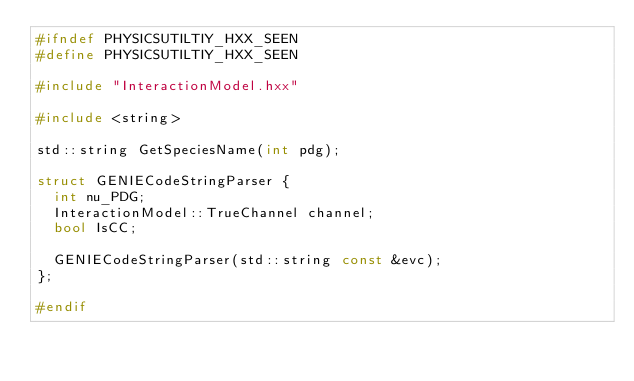<code> <loc_0><loc_0><loc_500><loc_500><_C++_>#ifndef PHYSICSUTILTIY_HXX_SEEN
#define PHYSICSUTILTIY_HXX_SEEN

#include "InteractionModel.hxx"

#include <string>

std::string GetSpeciesName(int pdg);

struct GENIECodeStringParser {
  int nu_PDG;
  InteractionModel::TrueChannel channel;
  bool IsCC;

  GENIECodeStringParser(std::string const &evc);
};

#endif
</code> 